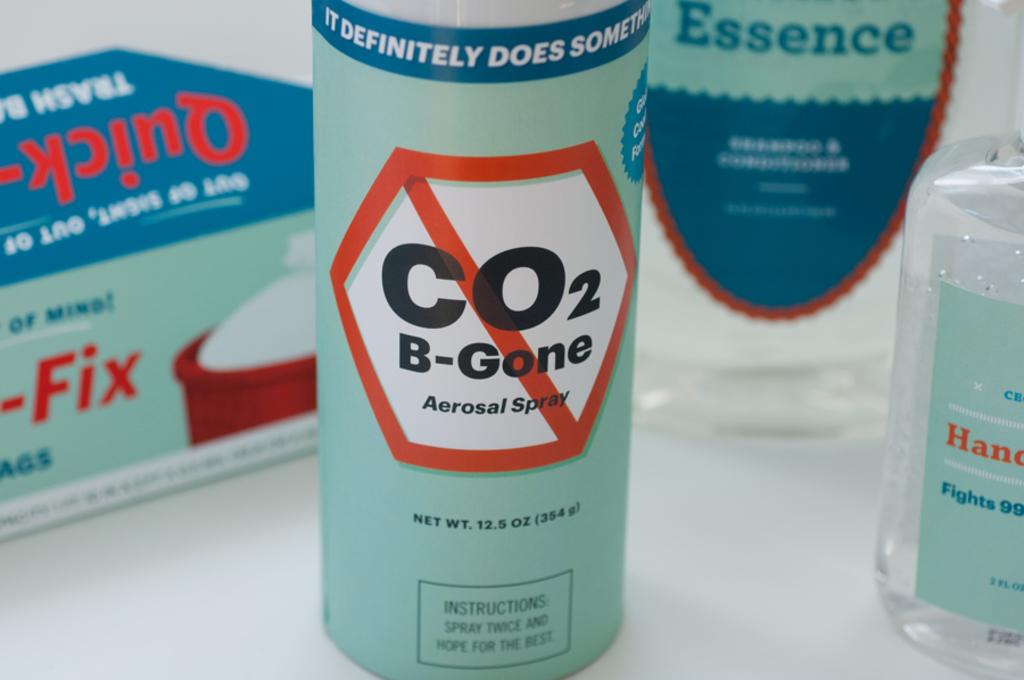How many ounces does this weigh?
Your answer should be compact. 12.5. Wha tis the name of the spray?
Ensure brevity in your answer.  Co2 b-gone. 